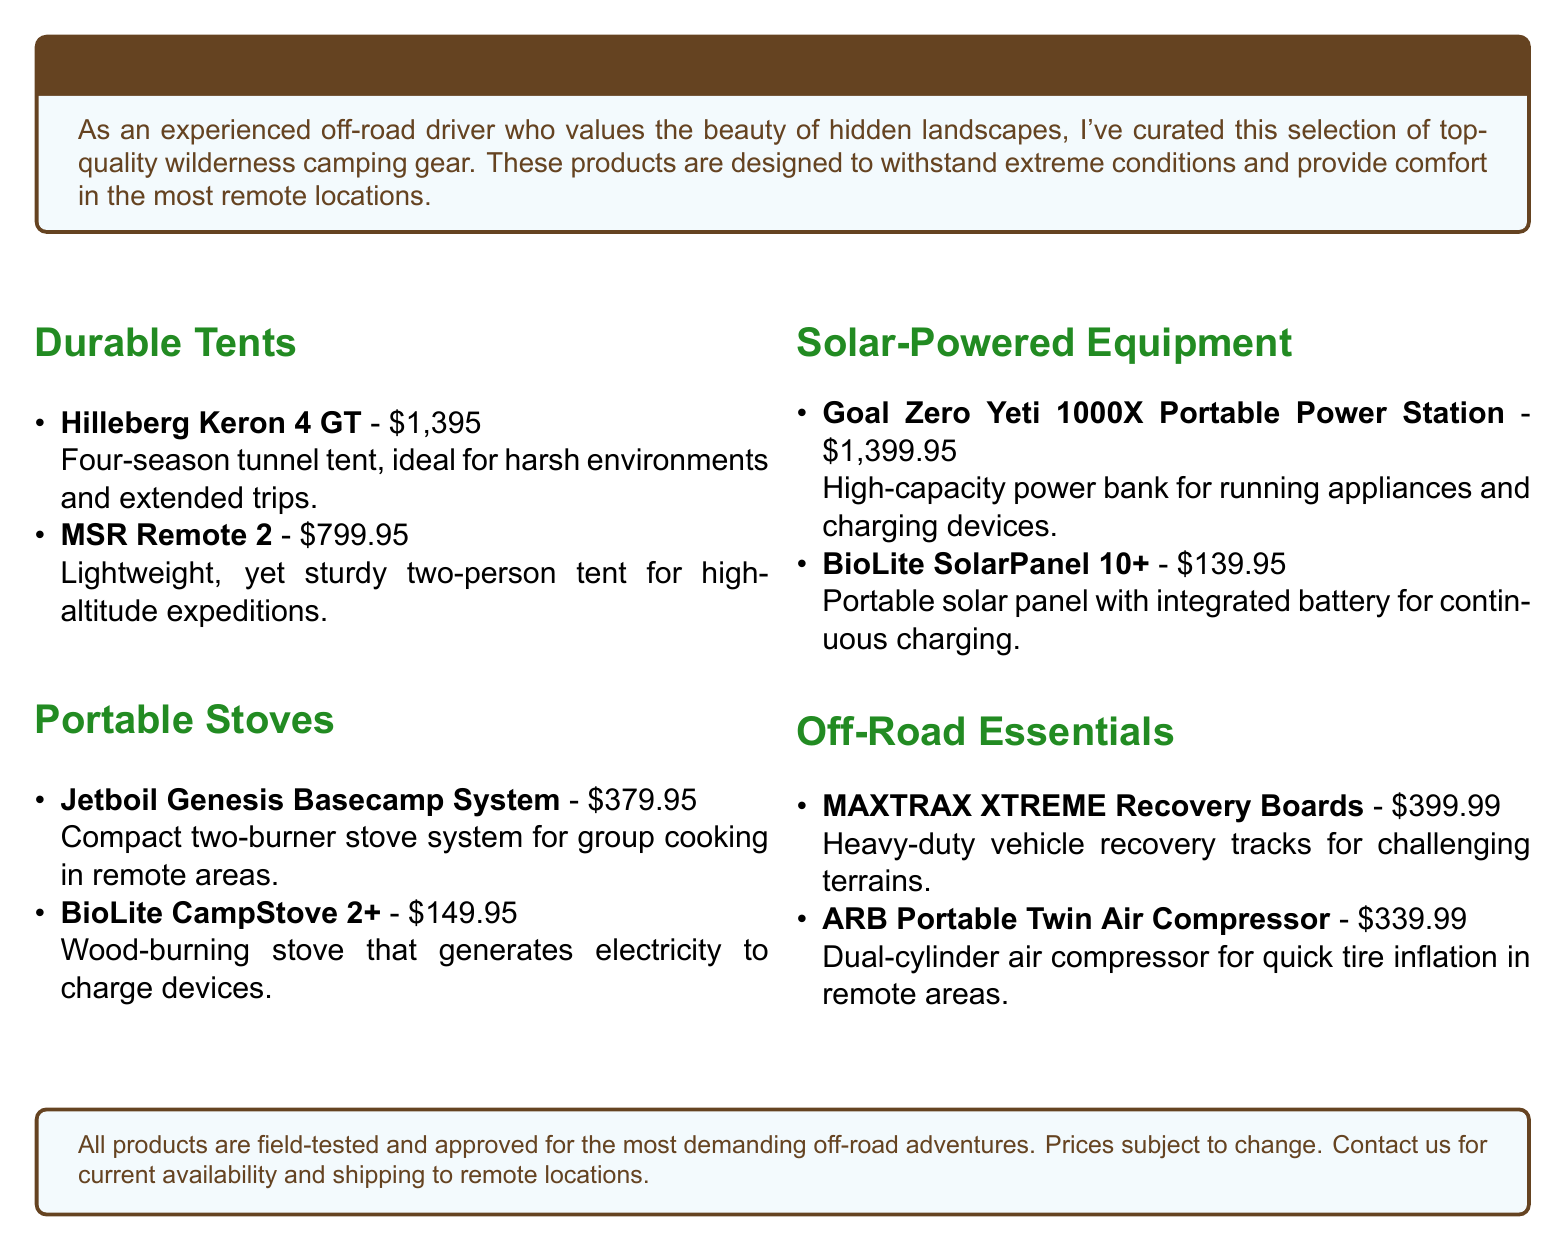what is the price of the Hilleberg Keron 4 GT? The price of the Hilleberg Keron 4 GT is listed in the document.
Answer: $1,395 how many people can the MSR Remote 2 tent accommodate? The document specifies that the MSR Remote 2 is a two-person tent.
Answer: two-person what is the capacity of the Goal Zero Yeti 1000X Portable Power Station? The document describes it as a high-capacity power bank.
Answer: high-capacity what type of fuel does the BioLite CampStove 2+ use? The document states that it is a wood-burning stove.
Answer: wood-burning which product provides charging capabilities while cooking? The document mentions a specific product that can charge devices while cooking.
Answer: BioLite CampStove 2+ what are MAXTRAX XTREME Recovery Boards used for? The document mentions these are used for vehicle recovery in challenging terrains.
Answer: vehicle recovery what is a feature of the BioLite SolarPanel 10+? The document highlights that it has an integrated battery for continuous charging.
Answer: integrated battery how much does the ARB Portable Twin Air Compressor cost? The document lists the price of the ARB Portable Twin Air Compressor.
Answer: $339.99 which tent is ideal for harsh environments? The document specifies the tent that is designed for harsh conditions.
Answer: Hilleberg Keron 4 GT 